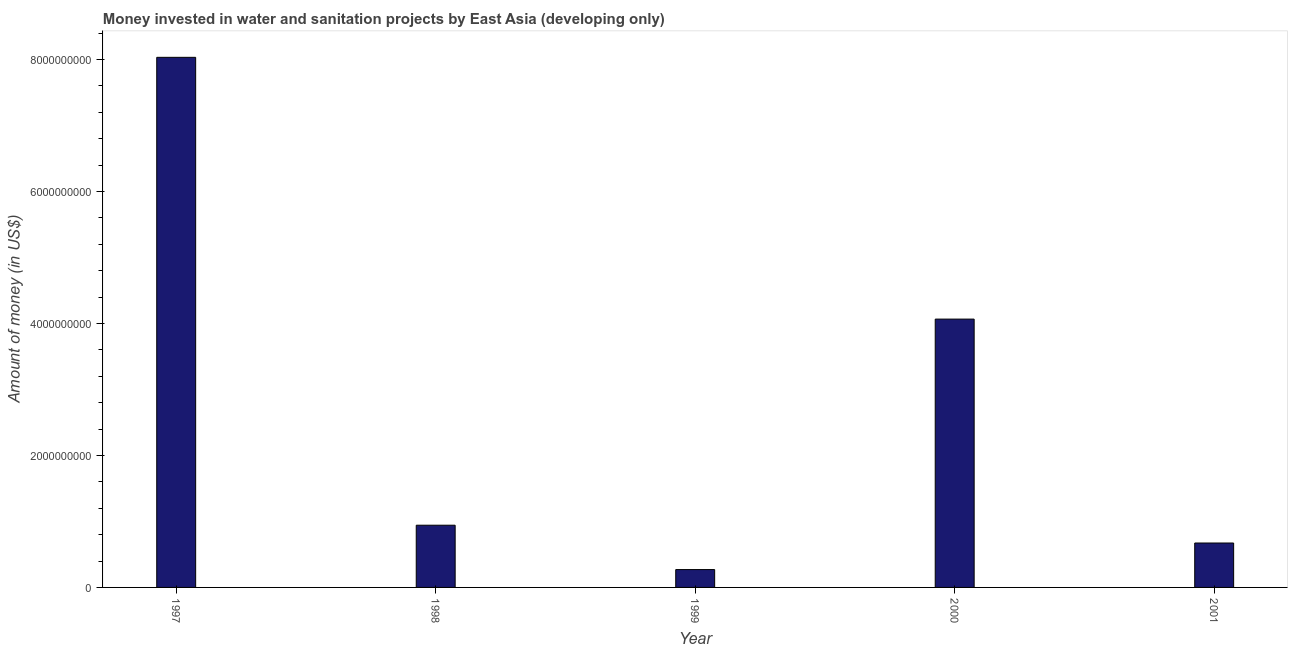Does the graph contain grids?
Offer a terse response. No. What is the title of the graph?
Ensure brevity in your answer.  Money invested in water and sanitation projects by East Asia (developing only). What is the label or title of the Y-axis?
Your response must be concise. Amount of money (in US$). What is the investment in 1999?
Give a very brief answer. 2.70e+08. Across all years, what is the maximum investment?
Your answer should be very brief. 8.03e+09. Across all years, what is the minimum investment?
Ensure brevity in your answer.  2.70e+08. What is the sum of the investment?
Give a very brief answer. 1.40e+1. What is the difference between the investment in 1998 and 1999?
Your response must be concise. 6.72e+08. What is the average investment per year?
Your response must be concise. 2.80e+09. What is the median investment?
Keep it short and to the point. 9.43e+08. In how many years, is the investment greater than 6400000000 US$?
Your response must be concise. 1. What is the ratio of the investment in 1999 to that in 2000?
Keep it short and to the point. 0.07. Is the difference between the investment in 1999 and 2000 greater than the difference between any two years?
Your answer should be very brief. No. What is the difference between the highest and the second highest investment?
Your response must be concise. 3.97e+09. What is the difference between the highest and the lowest investment?
Provide a succinct answer. 7.76e+09. How many years are there in the graph?
Keep it short and to the point. 5. Are the values on the major ticks of Y-axis written in scientific E-notation?
Your answer should be compact. No. What is the Amount of money (in US$) of 1997?
Make the answer very short. 8.03e+09. What is the Amount of money (in US$) in 1998?
Provide a short and direct response. 9.43e+08. What is the Amount of money (in US$) of 1999?
Your answer should be compact. 2.70e+08. What is the Amount of money (in US$) in 2000?
Your answer should be compact. 4.07e+09. What is the Amount of money (in US$) in 2001?
Your answer should be compact. 6.73e+08. What is the difference between the Amount of money (in US$) in 1997 and 1998?
Offer a very short reply. 7.09e+09. What is the difference between the Amount of money (in US$) in 1997 and 1999?
Provide a succinct answer. 7.76e+09. What is the difference between the Amount of money (in US$) in 1997 and 2000?
Keep it short and to the point. 3.97e+09. What is the difference between the Amount of money (in US$) in 1997 and 2001?
Offer a very short reply. 7.36e+09. What is the difference between the Amount of money (in US$) in 1998 and 1999?
Provide a succinct answer. 6.72e+08. What is the difference between the Amount of money (in US$) in 1998 and 2000?
Offer a terse response. -3.12e+09. What is the difference between the Amount of money (in US$) in 1998 and 2001?
Your answer should be compact. 2.70e+08. What is the difference between the Amount of money (in US$) in 1999 and 2000?
Provide a succinct answer. -3.80e+09. What is the difference between the Amount of money (in US$) in 1999 and 2001?
Offer a terse response. -4.02e+08. What is the difference between the Amount of money (in US$) in 2000 and 2001?
Your response must be concise. 3.39e+09. What is the ratio of the Amount of money (in US$) in 1997 to that in 1998?
Make the answer very short. 8.52. What is the ratio of the Amount of money (in US$) in 1997 to that in 1999?
Ensure brevity in your answer.  29.7. What is the ratio of the Amount of money (in US$) in 1997 to that in 2000?
Your answer should be very brief. 1.98. What is the ratio of the Amount of money (in US$) in 1997 to that in 2001?
Offer a very short reply. 11.94. What is the ratio of the Amount of money (in US$) in 1998 to that in 1999?
Offer a terse response. 3.48. What is the ratio of the Amount of money (in US$) in 1998 to that in 2000?
Provide a short and direct response. 0.23. What is the ratio of the Amount of money (in US$) in 1998 to that in 2001?
Provide a short and direct response. 1.4. What is the ratio of the Amount of money (in US$) in 1999 to that in 2000?
Your answer should be compact. 0.07. What is the ratio of the Amount of money (in US$) in 1999 to that in 2001?
Keep it short and to the point. 0.4. What is the ratio of the Amount of money (in US$) in 2000 to that in 2001?
Provide a short and direct response. 6.04. 